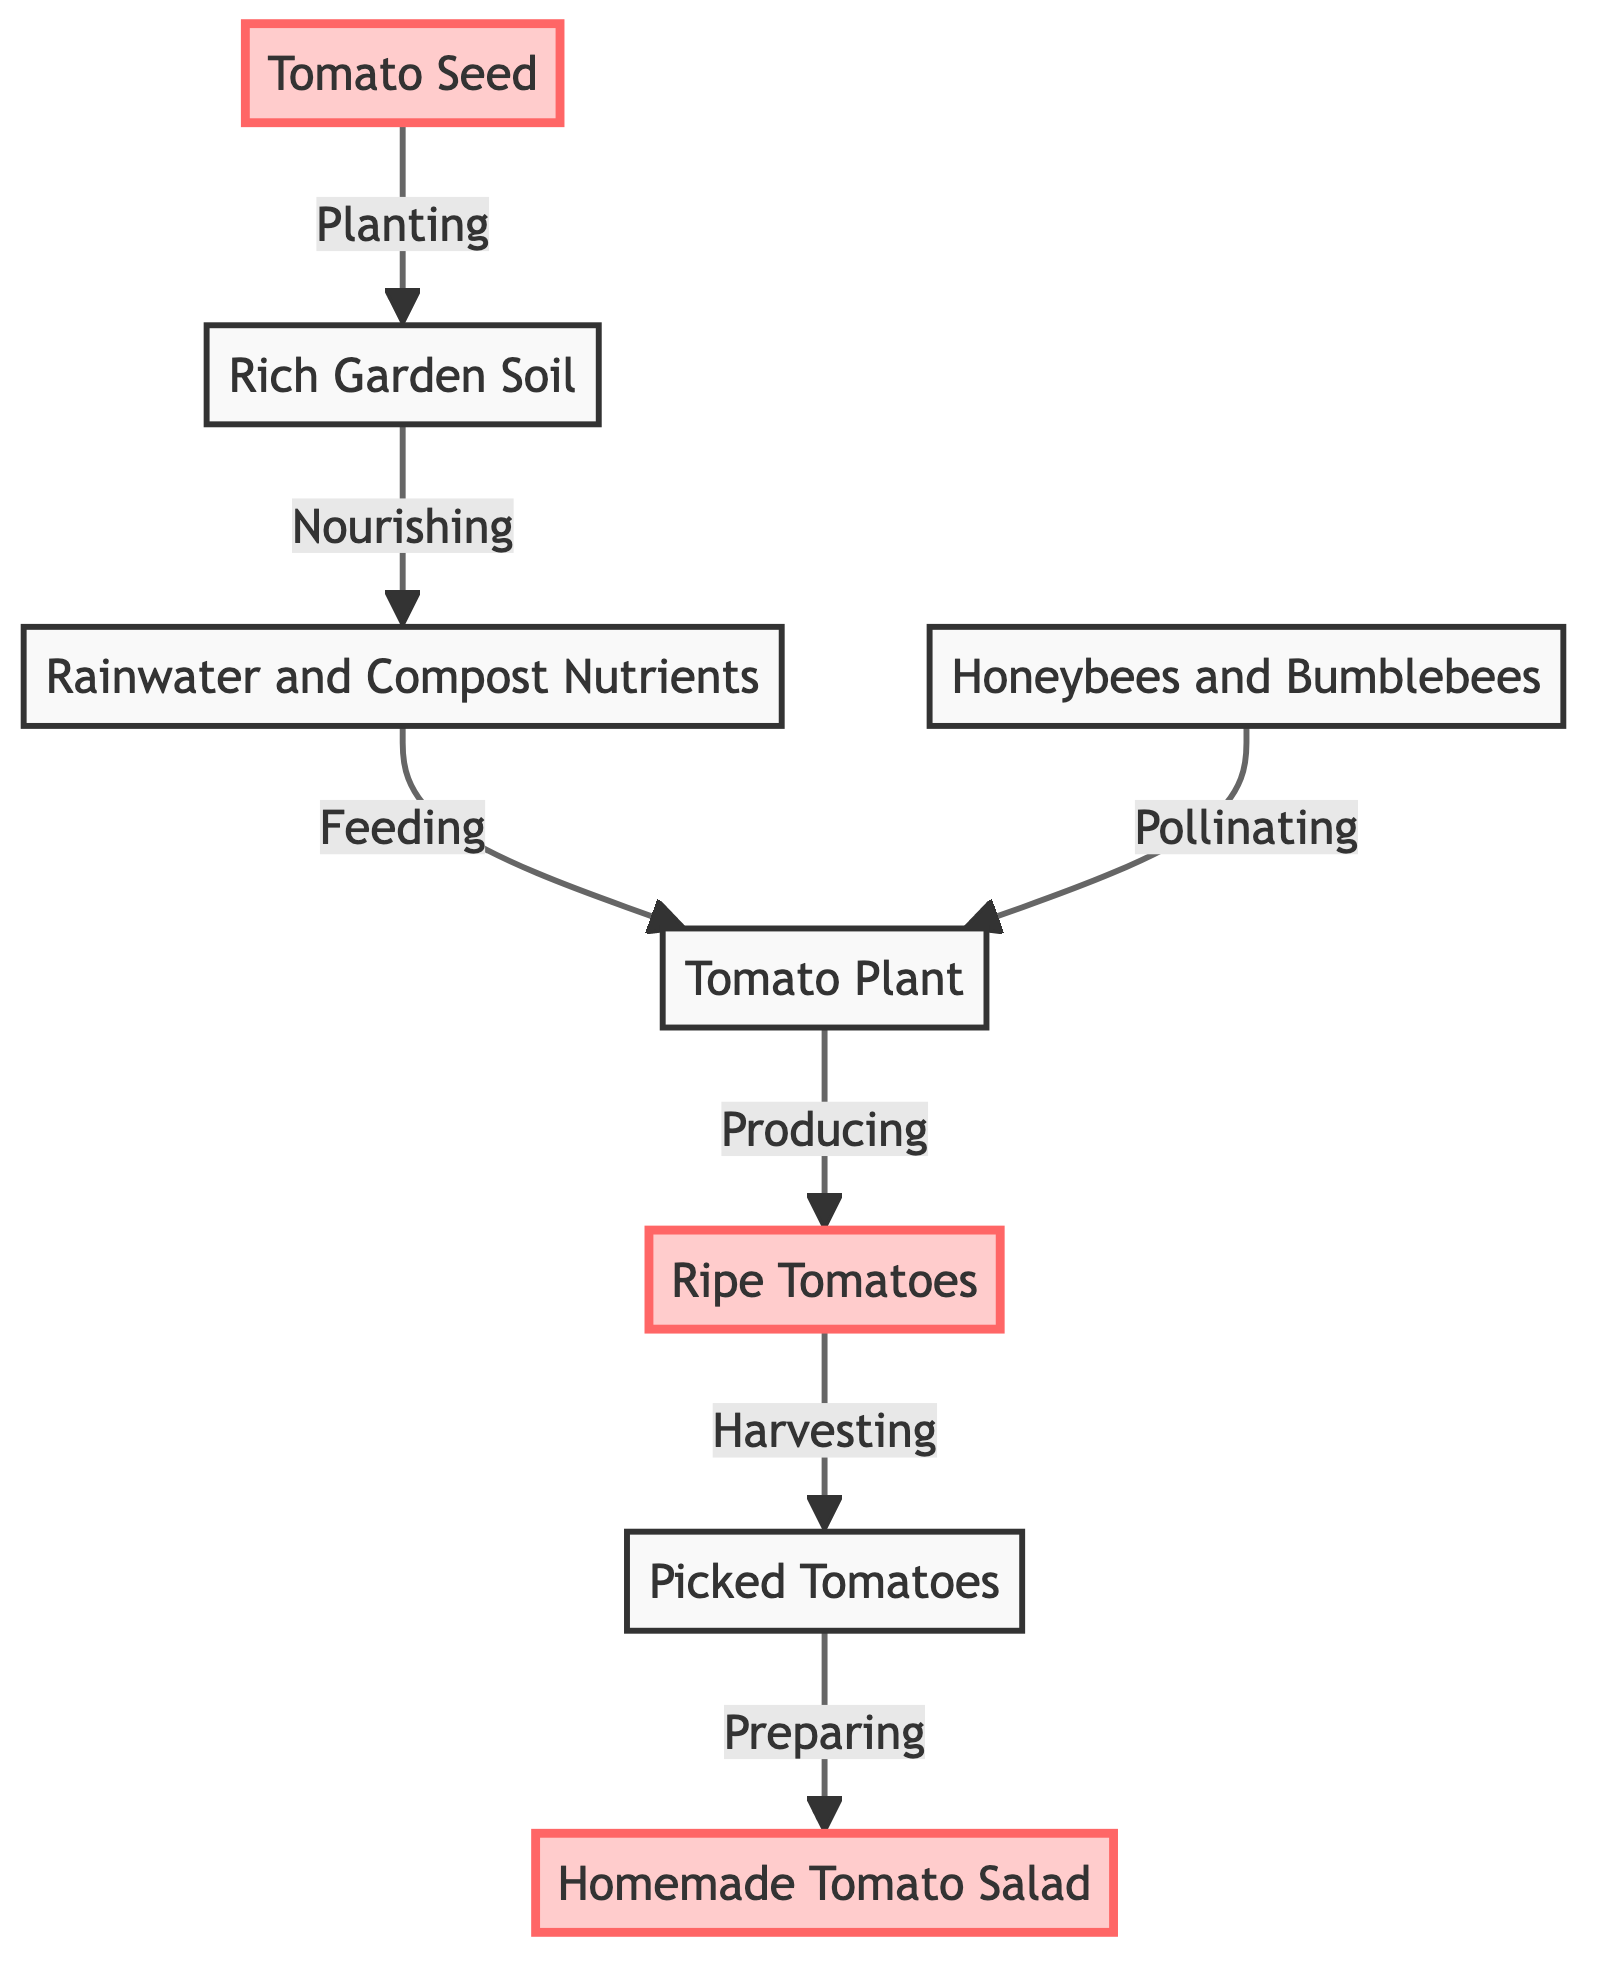What is the first step in the urban backyard food chain? The first step in the food chain is the planting of the Tomato Seed, which is represented by node A. This is the initial action that starts the growth process.
Answer: Tomato Seed Which node represents the product of the Tomato Plant? The node that represents the product of the Tomato Plant is F, which indicates the Ripe Tomatoes that are produced after the plant has grown.
Answer: Ripe Tomatoes How many main components are there in the food chain? By counting the nodes, we find a total of 8 main components in the food chain: Tomato Seed, Rich Garden Soil, Rainwater and Compost Nutrients, Honeybees and Bumblebees, Tomato Plant, Ripe Tomatoes, Picked Tomatoes, and Homemade Tomato Salad.
Answer: 8 What is the relationship between Honeybees and the Tomato Plant? The relationship is that Honeybees and Bumblebees are responsible for pollinating the Tomato Plant, as indicated by the arrow connecting node D to node E.
Answer: Pollinating What happens after Ripe Tomatoes are harvested? After Ripe Tomatoes, which is node F, are harvested, they move to the next step, which is represented by node G: Picked Tomatoes. This indicates the transition from gathering to processing.
Answer: Picked Tomatoes What nutrient source does the Tomato Plant rely on? The Tomato Plant, represented by node E, relies on Rainwater and Compost Nutrients for nourishment, as indicated by the arrow leading from C to E.
Answer: Rainwater and Compost Nutrients Which node indicates the final product of this food chain process? The final product of this food chain process is represented by node H, which is Homemade Tomato Salad, the culmination of all steps from planting to harvest and preparation.
Answer: Homemade Tomato Salad What does the Tomato Seed need to grow effectively? The Tomato Seed needs Rich Garden Soil in order to grow effectively, as indicated by the connection from node A to node B, which signifies the need for nutrient-rich planting conditions.
Answer: Rich Garden Soil 